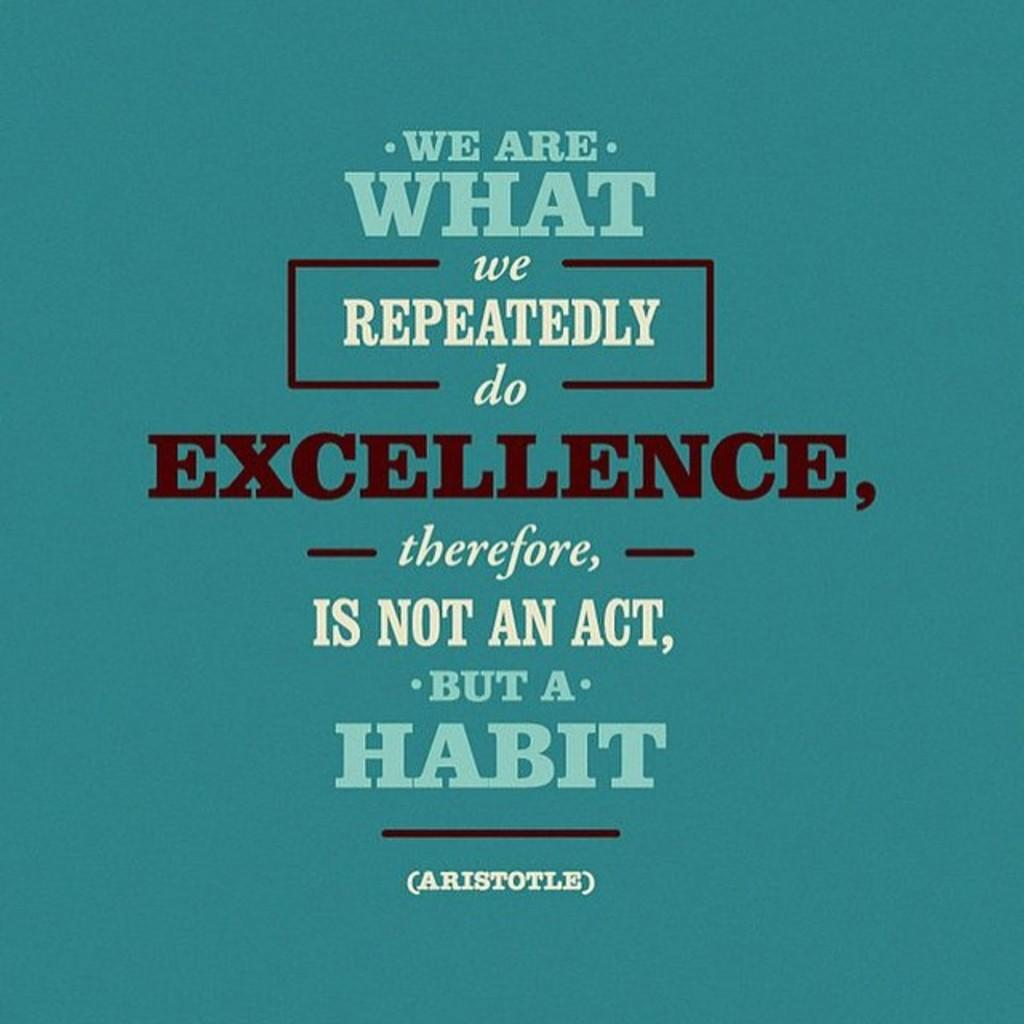Provide a one-sentence caption for the provided image. A blue poster with a quote from aristotle on it. 